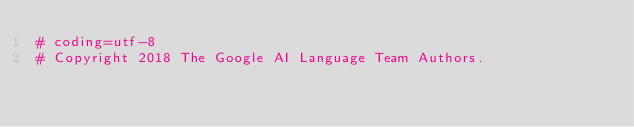<code> <loc_0><loc_0><loc_500><loc_500><_Python_># coding=utf-8
# Copyright 2018 The Google AI Language Team Authors.</code> 